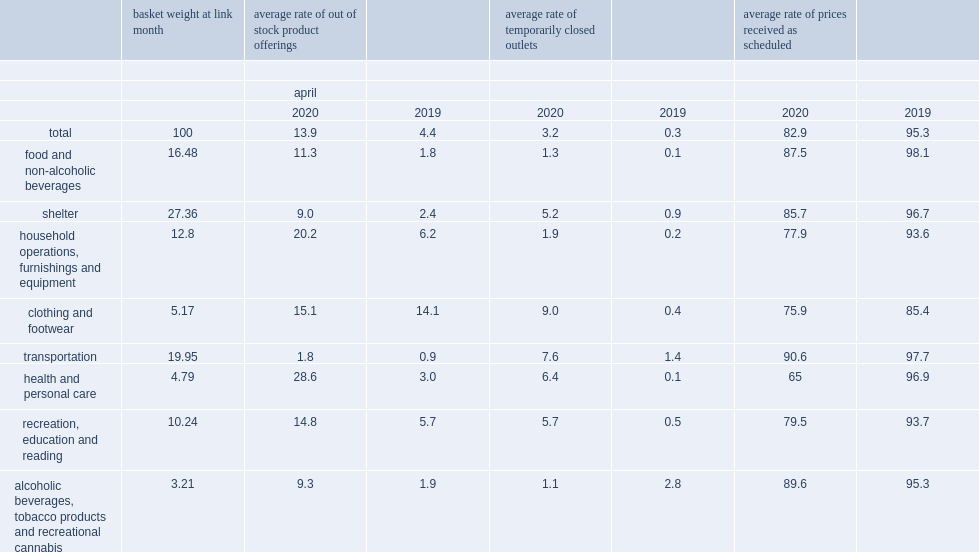What is the overall response rate of prices in the april 2020? 82.9. 